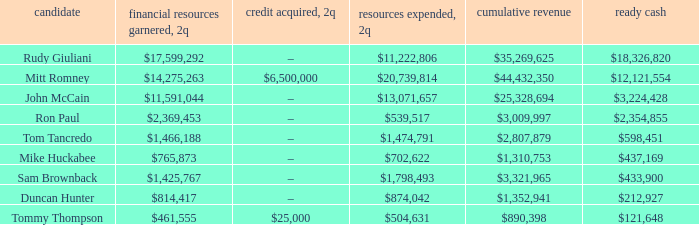How much money was generated when 2q received a total of $890,398 in income? $461,555. 